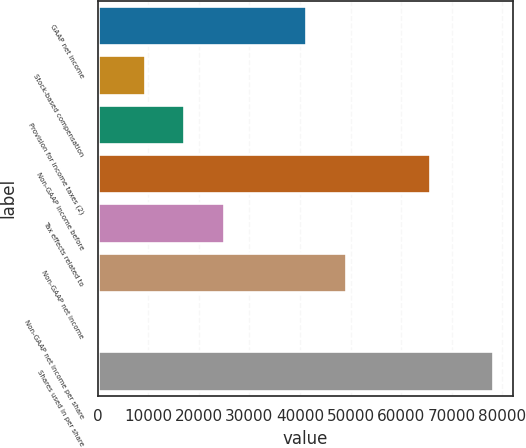Convert chart. <chart><loc_0><loc_0><loc_500><loc_500><bar_chart><fcel>GAAP net income<fcel>Stock-based compensation<fcel>Provision for income taxes (2)<fcel>Non-GAAP income before<fcel>Tax effects related to<fcel>Non-GAAP net income<fcel>Non-GAAP net income per share<fcel>Shares used in per share<nl><fcel>41245<fcel>9315<fcel>17135.2<fcel>65656<fcel>24955.5<fcel>49065.2<fcel>0.57<fcel>78203<nl></chart> 